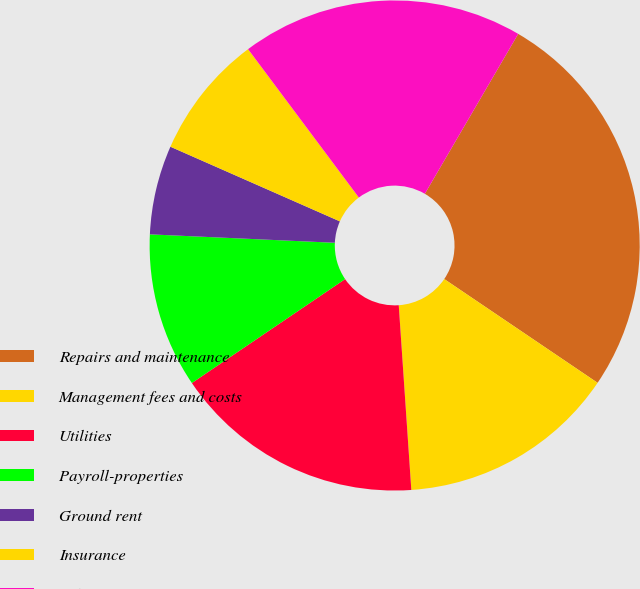Convert chart. <chart><loc_0><loc_0><loc_500><loc_500><pie_chart><fcel>Repairs and maintenance<fcel>Management fees and costs<fcel>Utilities<fcel>Payroll-properties<fcel>Ground rent<fcel>Insurance<fcel>Other<nl><fcel>26.06%<fcel>14.45%<fcel>16.6%<fcel>10.21%<fcel>5.88%<fcel>8.19%<fcel>18.62%<nl></chart> 